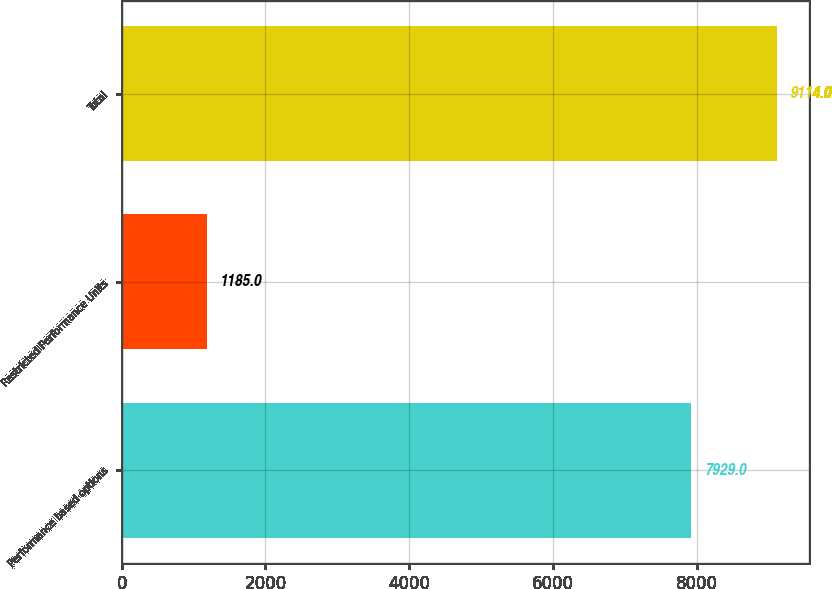<chart> <loc_0><loc_0><loc_500><loc_500><bar_chart><fcel>Performance based options<fcel>Restricted Performance Units<fcel>Total<nl><fcel>7929<fcel>1185<fcel>9114<nl></chart> 